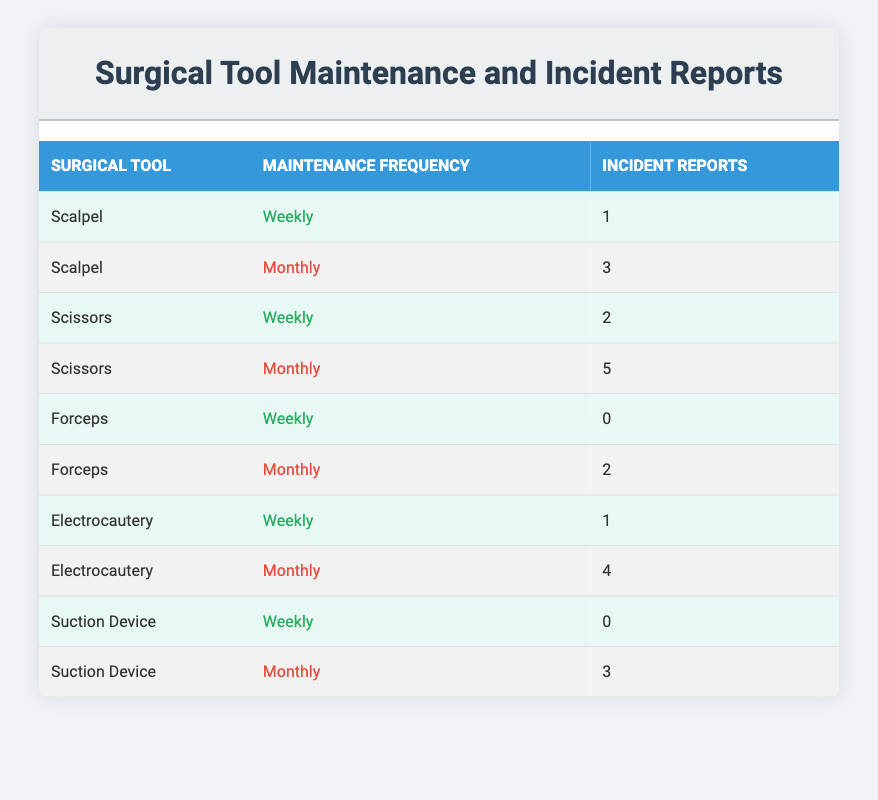What is the incident report number for the scalpel with monthly maintenance? From the table, we can find the row that lists the scalpel under monthly maintenance, which shows 3 incident reports.
Answer: 3 How many incident reports are there for forceps with weekly maintenance? Looking at the table, the incident report number for forceps with weekly maintenance is listed as 0.
Answer: 0 Which surgical tool has the highest number of incident reports with monthly maintenance? By comparing the incident reports for all tools with monthly maintenance, the scissors show the highest at 5 reports.
Answer: Scissors What is the total number of incident reports for all tools that have weekly maintenance? Adding the incident reports for all tools with weekly maintenance: 1 (scalpel) + 2 (scissors) + 0 (forceps) + 1 (electrocautery) + 0 (suction device) = 4.
Answer: 4 Is the statement "Electrocautery has more incident reports with monthly maintenance than the scalpel" true? Checking the table, the electrocautery shows 4 incident reports for monthly maintenance, while the scalpel shows 3. Therefore, the statement is true.
Answer: Yes What is the difference in incident reports between the monthly maintenance of scissors and forceps? Scissors have 5 incident reports while forceps have 2. The difference is calculated as 5 - 2 = 3.
Answer: 3 What is the average incident report number for surgical tools that are maintained weekly? Summing the incident reports for tools with weekly maintenance: 1 (scalpel) + 2 (scissors) + 0 (forceps) + 1 (electrocautery) + 0 (suction device) gives a total of 4, and dividing by the 5 tools gives 4/5 = 0.8.
Answer: 0.8 How many tools report incident numbers of 3 or more with monthly maintenance? By examining the table for monthly maintenance, we find that scissors (5) and electrocautery (4) both have incident reports of 3 or more, totaling 2 tools.
Answer: 2 Which surgical tool has the fewest incident reports across all maintenance frequencies? Looking through the table, forceps have the lowest incident report count, with 0 incidents for weekly maintenance and 2 incidents for monthly maintenance, so the minimum is 0.
Answer: 0 